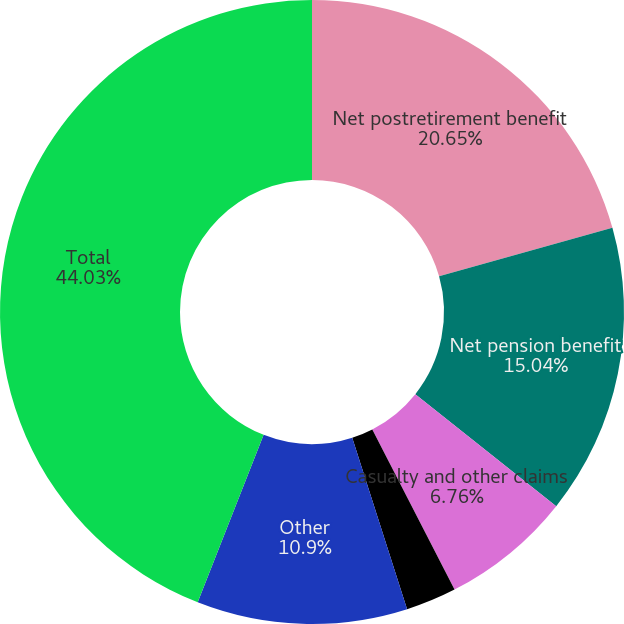Convert chart. <chart><loc_0><loc_0><loc_500><loc_500><pie_chart><fcel>Net postretirement benefit<fcel>Net pension benefit<fcel>Casualty and other claims<fcel>Long-term advances from<fcel>Other<fcel>Total<nl><fcel>20.65%<fcel>15.04%<fcel>6.76%<fcel>2.62%<fcel>10.9%<fcel>44.03%<nl></chart> 